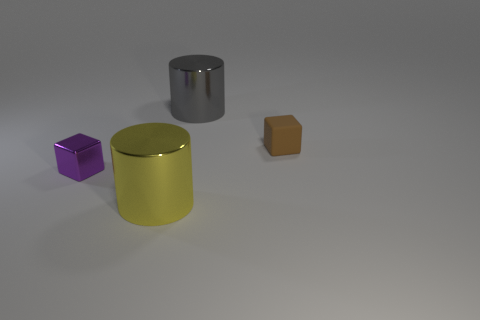Are there more big gray shiny things that are on the left side of the small brown cube than small purple rubber things?
Offer a very short reply. Yes. How many things are either big blue spheres or small purple things?
Your response must be concise. 1. What is the color of the tiny rubber object?
Your response must be concise. Brown. Are there any yellow cylinders in front of the gray object?
Your answer should be very brief. Yes. There is a cylinder in front of the large shiny cylinder that is behind the large thing that is to the left of the gray metal thing; what is its color?
Offer a terse response. Yellow. What number of things are to the left of the rubber block and in front of the gray shiny cylinder?
Provide a short and direct response. 2. How many blocks are either large yellow things or big metallic objects?
Your response must be concise. 0. Are any small brown matte objects visible?
Provide a short and direct response. Yes. What number of other things are made of the same material as the brown object?
Ensure brevity in your answer.  0. What is the material of the cylinder that is the same size as the yellow object?
Ensure brevity in your answer.  Metal. 